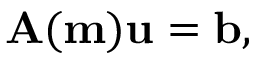Convert formula to latex. <formula><loc_0><loc_0><loc_500><loc_500>A ( m ) u = b ,</formula> 